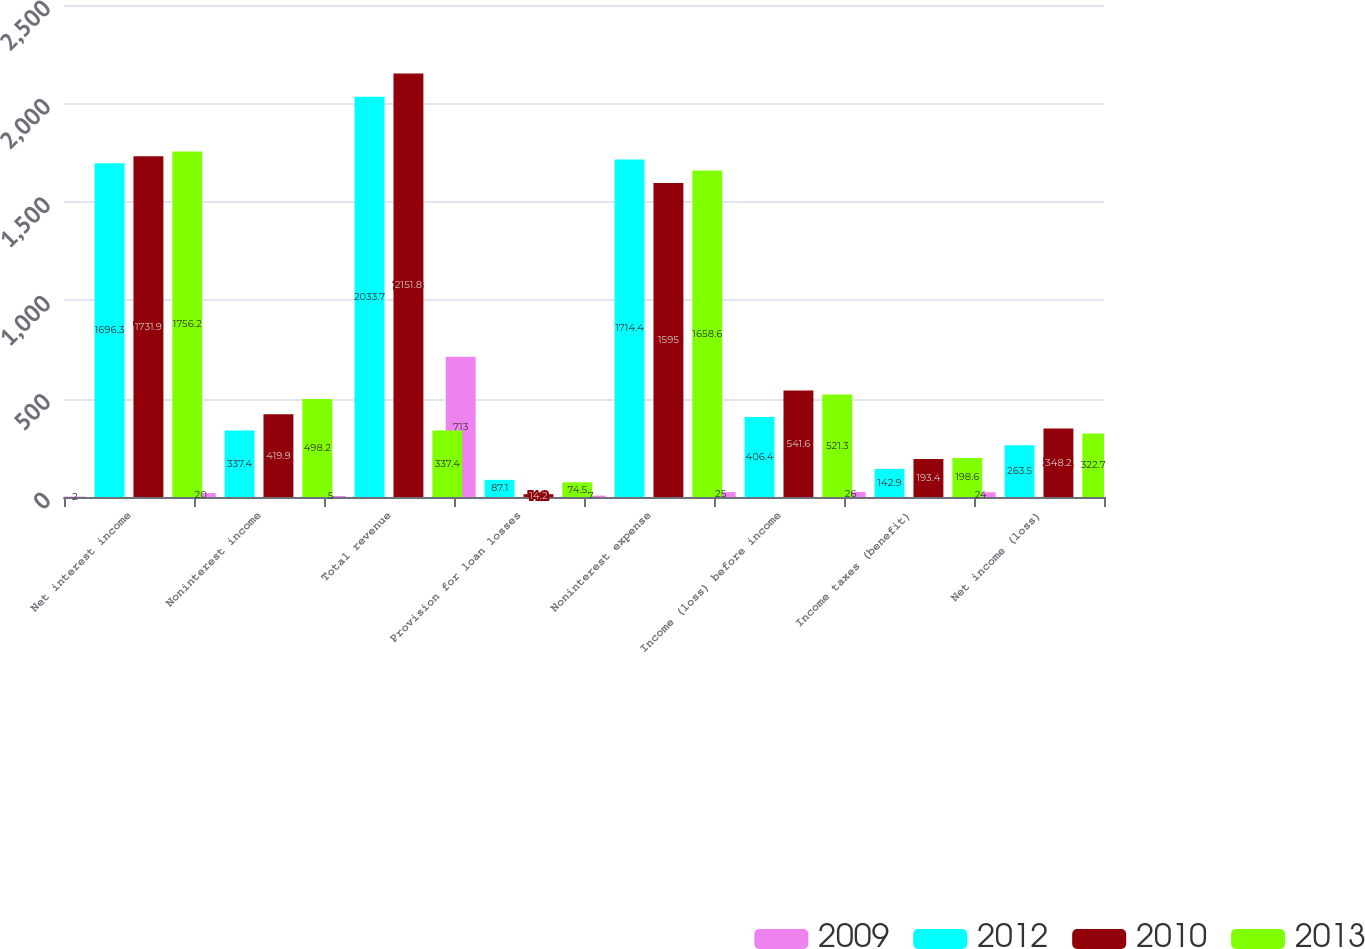Convert chart to OTSL. <chart><loc_0><loc_0><loc_500><loc_500><stacked_bar_chart><ecel><fcel>Net interest income<fcel>Noninterest income<fcel>Total revenue<fcel>Provision for loan losses<fcel>Noninterest expense<fcel>Income (loss) before income<fcel>Income taxes (benefit)<fcel>Net income (loss)<nl><fcel>2009<fcel>2<fcel>20<fcel>5<fcel>713<fcel>7<fcel>25<fcel>26<fcel>24<nl><fcel>2012<fcel>1696.3<fcel>337.4<fcel>2033.7<fcel>87.1<fcel>1714.4<fcel>406.4<fcel>142.9<fcel>263.5<nl><fcel>2010<fcel>1731.9<fcel>419.9<fcel>2151.8<fcel>14.2<fcel>1595<fcel>541.6<fcel>193.4<fcel>348.2<nl><fcel>2013<fcel>1756.2<fcel>498.2<fcel>337.4<fcel>74.5<fcel>1658.6<fcel>521.3<fcel>198.6<fcel>322.7<nl></chart> 